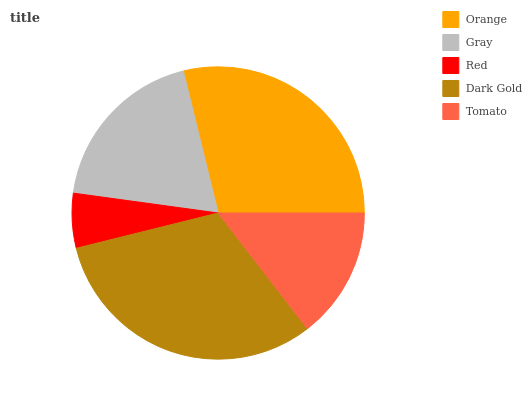Is Red the minimum?
Answer yes or no. Yes. Is Dark Gold the maximum?
Answer yes or no. Yes. Is Gray the minimum?
Answer yes or no. No. Is Gray the maximum?
Answer yes or no. No. Is Orange greater than Gray?
Answer yes or no. Yes. Is Gray less than Orange?
Answer yes or no. Yes. Is Gray greater than Orange?
Answer yes or no. No. Is Orange less than Gray?
Answer yes or no. No. Is Gray the high median?
Answer yes or no. Yes. Is Gray the low median?
Answer yes or no. Yes. Is Tomato the high median?
Answer yes or no. No. Is Dark Gold the low median?
Answer yes or no. No. 